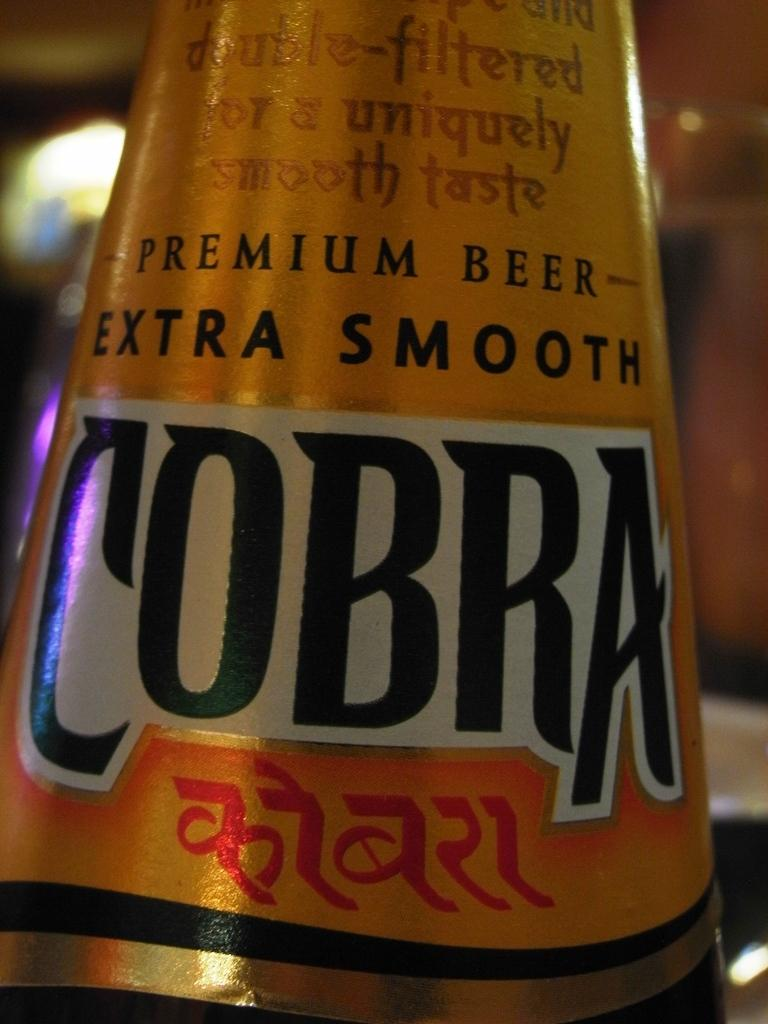<image>
Summarize the visual content of the image. the neck of a beer bottle that is labeled as pemium beer-extra smooth cobra 